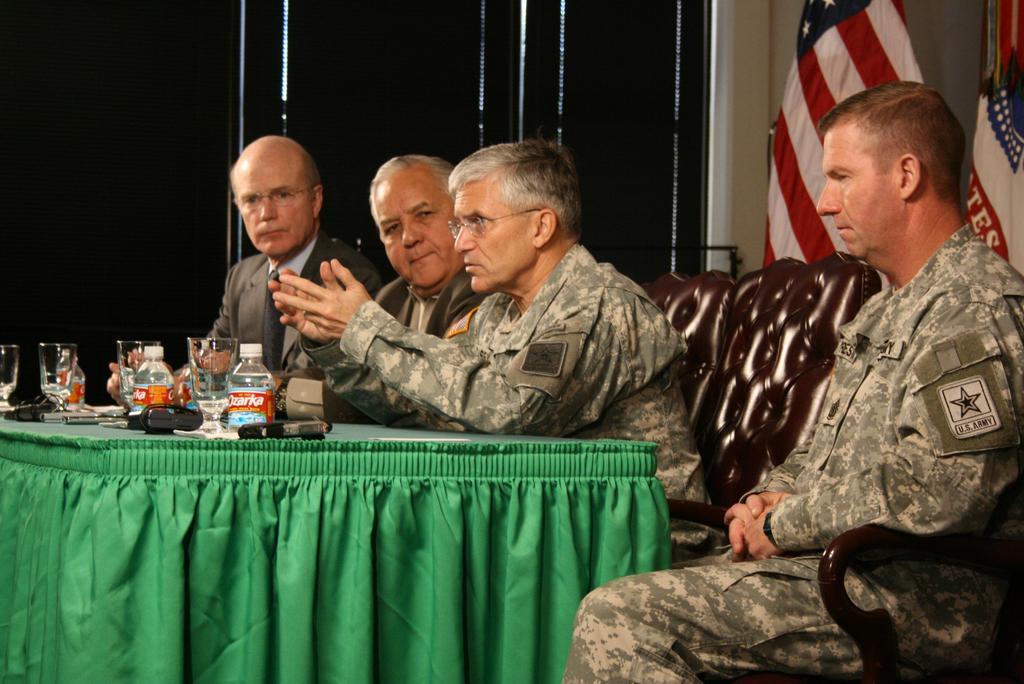Describe this image in one or two sentences. In this image we can see people sitting on chairs. There is a table on which there are bottles, glasses and other objects. To the right side of the image there are flags. 